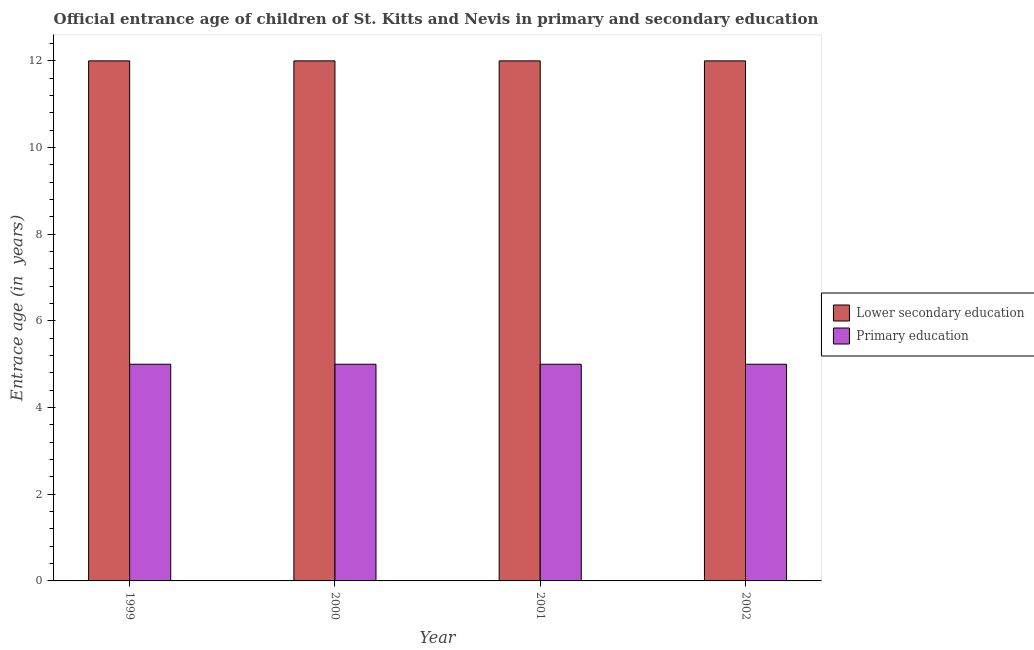Are the number of bars per tick equal to the number of legend labels?
Your response must be concise. Yes. Are the number of bars on each tick of the X-axis equal?
Provide a short and direct response. Yes. How many bars are there on the 4th tick from the left?
Provide a succinct answer. 2. What is the label of the 3rd group of bars from the left?
Your response must be concise. 2001. What is the entrance age of chiildren in primary education in 1999?
Keep it short and to the point. 5. Across all years, what is the maximum entrance age of children in lower secondary education?
Your answer should be compact. 12. Across all years, what is the minimum entrance age of children in lower secondary education?
Offer a very short reply. 12. In which year was the entrance age of chiildren in primary education maximum?
Ensure brevity in your answer.  1999. What is the total entrance age of chiildren in primary education in the graph?
Keep it short and to the point. 20. What is the average entrance age of chiildren in primary education per year?
Your answer should be very brief. 5. In the year 2002, what is the difference between the entrance age of children in lower secondary education and entrance age of chiildren in primary education?
Provide a short and direct response. 0. In how many years, is the entrance age of children in lower secondary education greater than 2.4 years?
Ensure brevity in your answer.  4. What is the ratio of the entrance age of chiildren in primary education in 2000 to that in 2001?
Provide a short and direct response. 1. What is the difference between the highest and the second highest entrance age of chiildren in primary education?
Ensure brevity in your answer.  0. What is the difference between the highest and the lowest entrance age of children in lower secondary education?
Your answer should be very brief. 0. In how many years, is the entrance age of children in lower secondary education greater than the average entrance age of children in lower secondary education taken over all years?
Keep it short and to the point. 0. Is the sum of the entrance age of chiildren in primary education in 2000 and 2002 greater than the maximum entrance age of children in lower secondary education across all years?
Your response must be concise. Yes. What does the 1st bar from the left in 2001 represents?
Your answer should be compact. Lower secondary education. What does the 2nd bar from the right in 1999 represents?
Give a very brief answer. Lower secondary education. How many years are there in the graph?
Offer a terse response. 4. What is the difference between two consecutive major ticks on the Y-axis?
Your answer should be compact. 2. Are the values on the major ticks of Y-axis written in scientific E-notation?
Give a very brief answer. No. Does the graph contain any zero values?
Your answer should be compact. No. How are the legend labels stacked?
Offer a very short reply. Vertical. What is the title of the graph?
Provide a short and direct response. Official entrance age of children of St. Kitts and Nevis in primary and secondary education. Does "Under-5(male)" appear as one of the legend labels in the graph?
Your answer should be compact. No. What is the label or title of the Y-axis?
Ensure brevity in your answer.  Entrace age (in  years). What is the Entrace age (in  years) of Primary education in 1999?
Offer a terse response. 5. What is the Entrace age (in  years) in Lower secondary education in 2000?
Provide a short and direct response. 12. What is the Entrace age (in  years) of Lower secondary education in 2001?
Keep it short and to the point. 12. What is the Entrace age (in  years) of Primary education in 2001?
Make the answer very short. 5. What is the Entrace age (in  years) of Primary education in 2002?
Provide a short and direct response. 5. What is the difference between the Entrace age (in  years) in Lower secondary education in 1999 and that in 2000?
Your answer should be compact. 0. What is the difference between the Entrace age (in  years) in Lower secondary education in 1999 and that in 2001?
Give a very brief answer. 0. What is the difference between the Entrace age (in  years) in Primary education in 2000 and that in 2001?
Provide a succinct answer. 0. What is the difference between the Entrace age (in  years) of Lower secondary education in 2000 and that in 2002?
Your answer should be compact. 0. What is the difference between the Entrace age (in  years) in Primary education in 2000 and that in 2002?
Give a very brief answer. 0. What is the difference between the Entrace age (in  years) in Lower secondary education in 2001 and that in 2002?
Offer a very short reply. 0. What is the difference between the Entrace age (in  years) in Primary education in 2001 and that in 2002?
Offer a terse response. 0. What is the difference between the Entrace age (in  years) in Lower secondary education in 1999 and the Entrace age (in  years) in Primary education in 2002?
Give a very brief answer. 7. What is the difference between the Entrace age (in  years) of Lower secondary education in 2000 and the Entrace age (in  years) of Primary education in 2001?
Your response must be concise. 7. What is the average Entrace age (in  years) of Lower secondary education per year?
Ensure brevity in your answer.  12. What is the average Entrace age (in  years) of Primary education per year?
Ensure brevity in your answer.  5. In the year 2000, what is the difference between the Entrace age (in  years) of Lower secondary education and Entrace age (in  years) of Primary education?
Keep it short and to the point. 7. In the year 2002, what is the difference between the Entrace age (in  years) of Lower secondary education and Entrace age (in  years) of Primary education?
Ensure brevity in your answer.  7. What is the ratio of the Entrace age (in  years) in Primary education in 1999 to that in 2000?
Ensure brevity in your answer.  1. What is the ratio of the Entrace age (in  years) in Lower secondary education in 1999 to that in 2001?
Offer a very short reply. 1. What is the ratio of the Entrace age (in  years) of Primary education in 1999 to that in 2001?
Offer a very short reply. 1. What is the ratio of the Entrace age (in  years) in Lower secondary education in 1999 to that in 2002?
Give a very brief answer. 1. What is the ratio of the Entrace age (in  years) in Primary education in 1999 to that in 2002?
Make the answer very short. 1. What is the ratio of the Entrace age (in  years) of Lower secondary education in 2000 to that in 2001?
Provide a succinct answer. 1. What is the ratio of the Entrace age (in  years) of Primary education in 2000 to that in 2001?
Your response must be concise. 1. What is the difference between the highest and the lowest Entrace age (in  years) of Lower secondary education?
Keep it short and to the point. 0. 